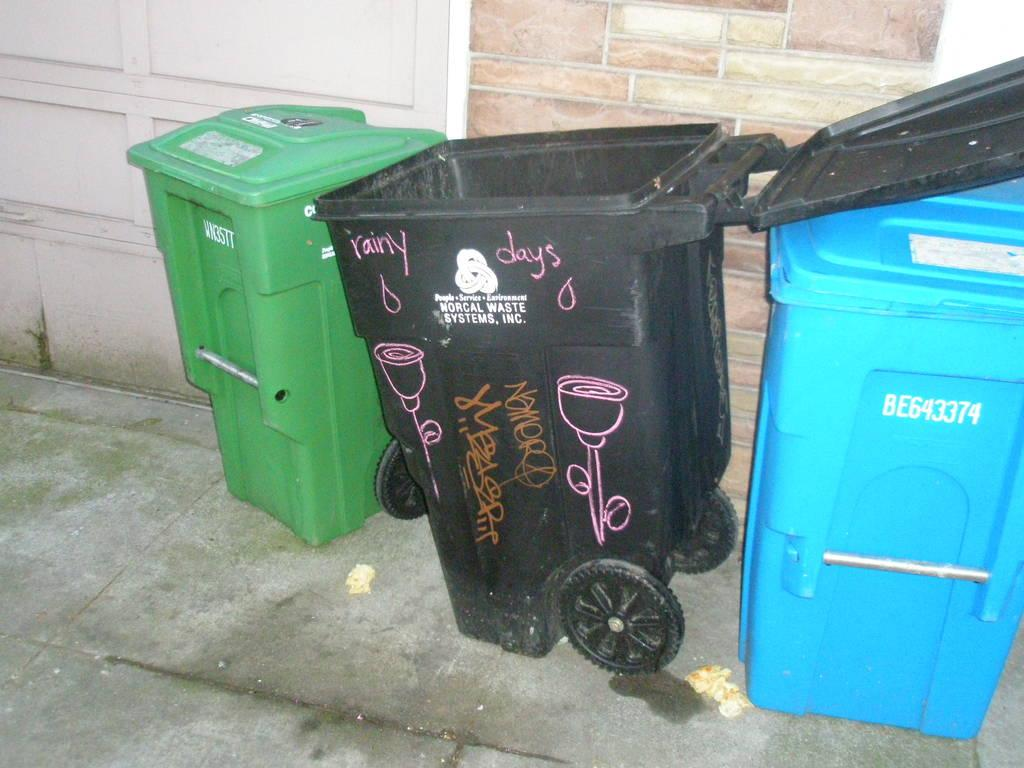Provide a one-sentence caption for the provided image. The black bin has Norcal Waste Systems, Inc written on it. 